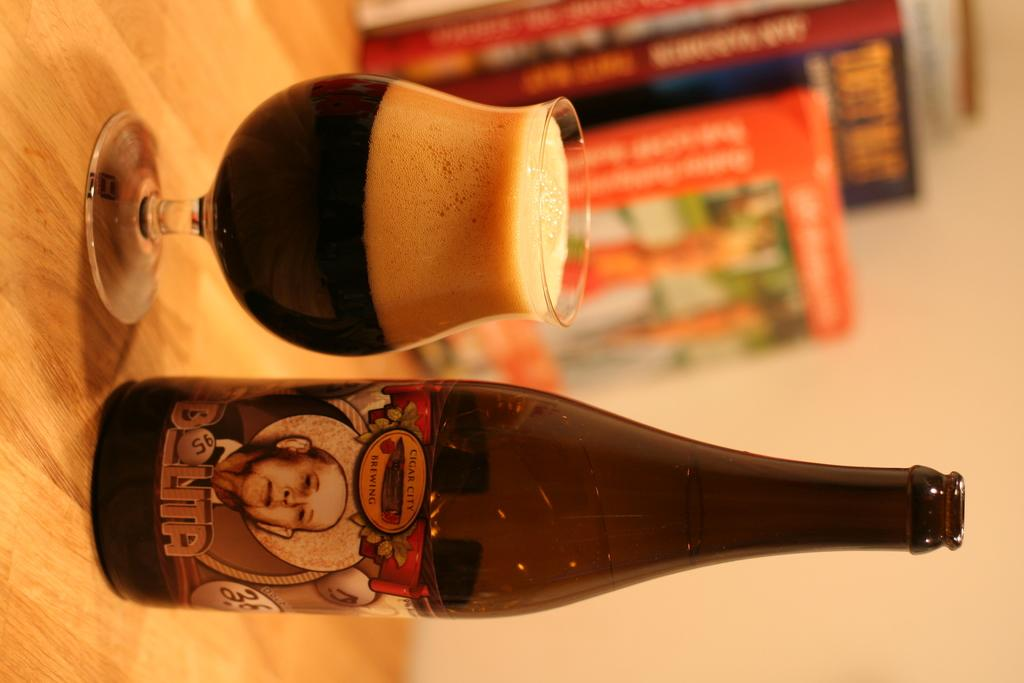What is one of the objects on the table in the image? There is a bottle on the table in the image. What is in the glass that is also on the table? There is a drink in the glass on the table. What type of items can be seen on the table besides the bottle and glass? There are books on the table in the image. What is the surface of the table made of? The objects are placed on a wooden table. What can be seen in the background of the image? There is a wall in the background of the image. What type of bubble is floating near the books in the image? There is no bubble present in the image. Can you tell me if the drink in the glass is poisonous? There is no information about the drink's contents in the image, so it cannot be determined if it is poisonous. 